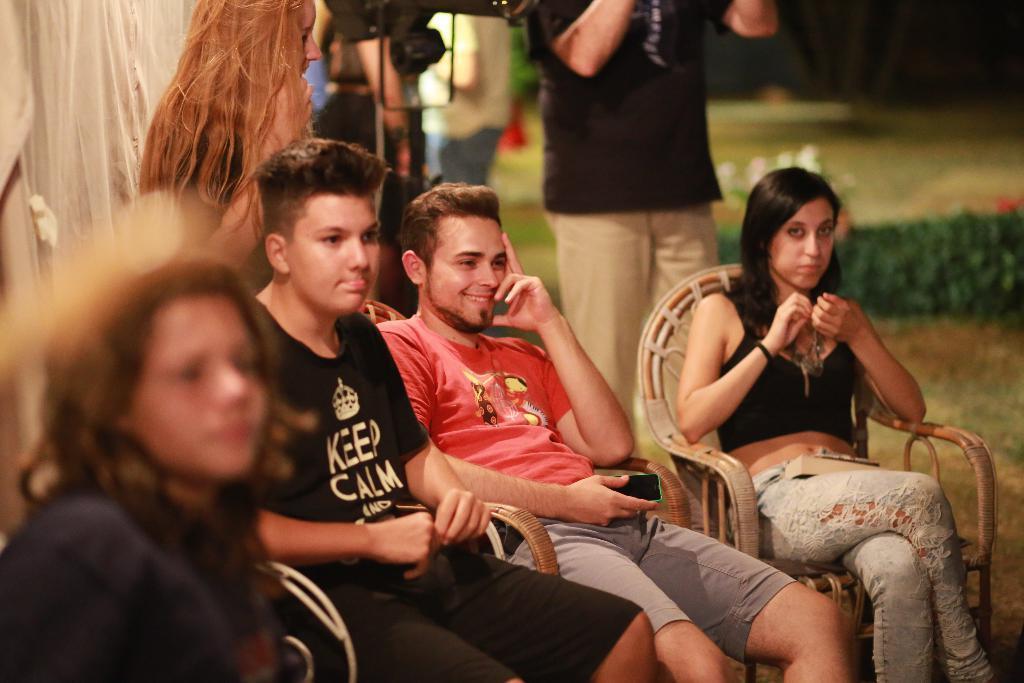Describe this image in one or two sentences. In this image i can see 2 men and 2 women sitting on chairs. In the background i can see few persons standing, plants and grass. 